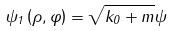Convert formula to latex. <formula><loc_0><loc_0><loc_500><loc_500>\psi _ { 1 } \left ( \rho , \varphi \right ) = \sqrt { k _ { 0 } + m } \psi</formula> 